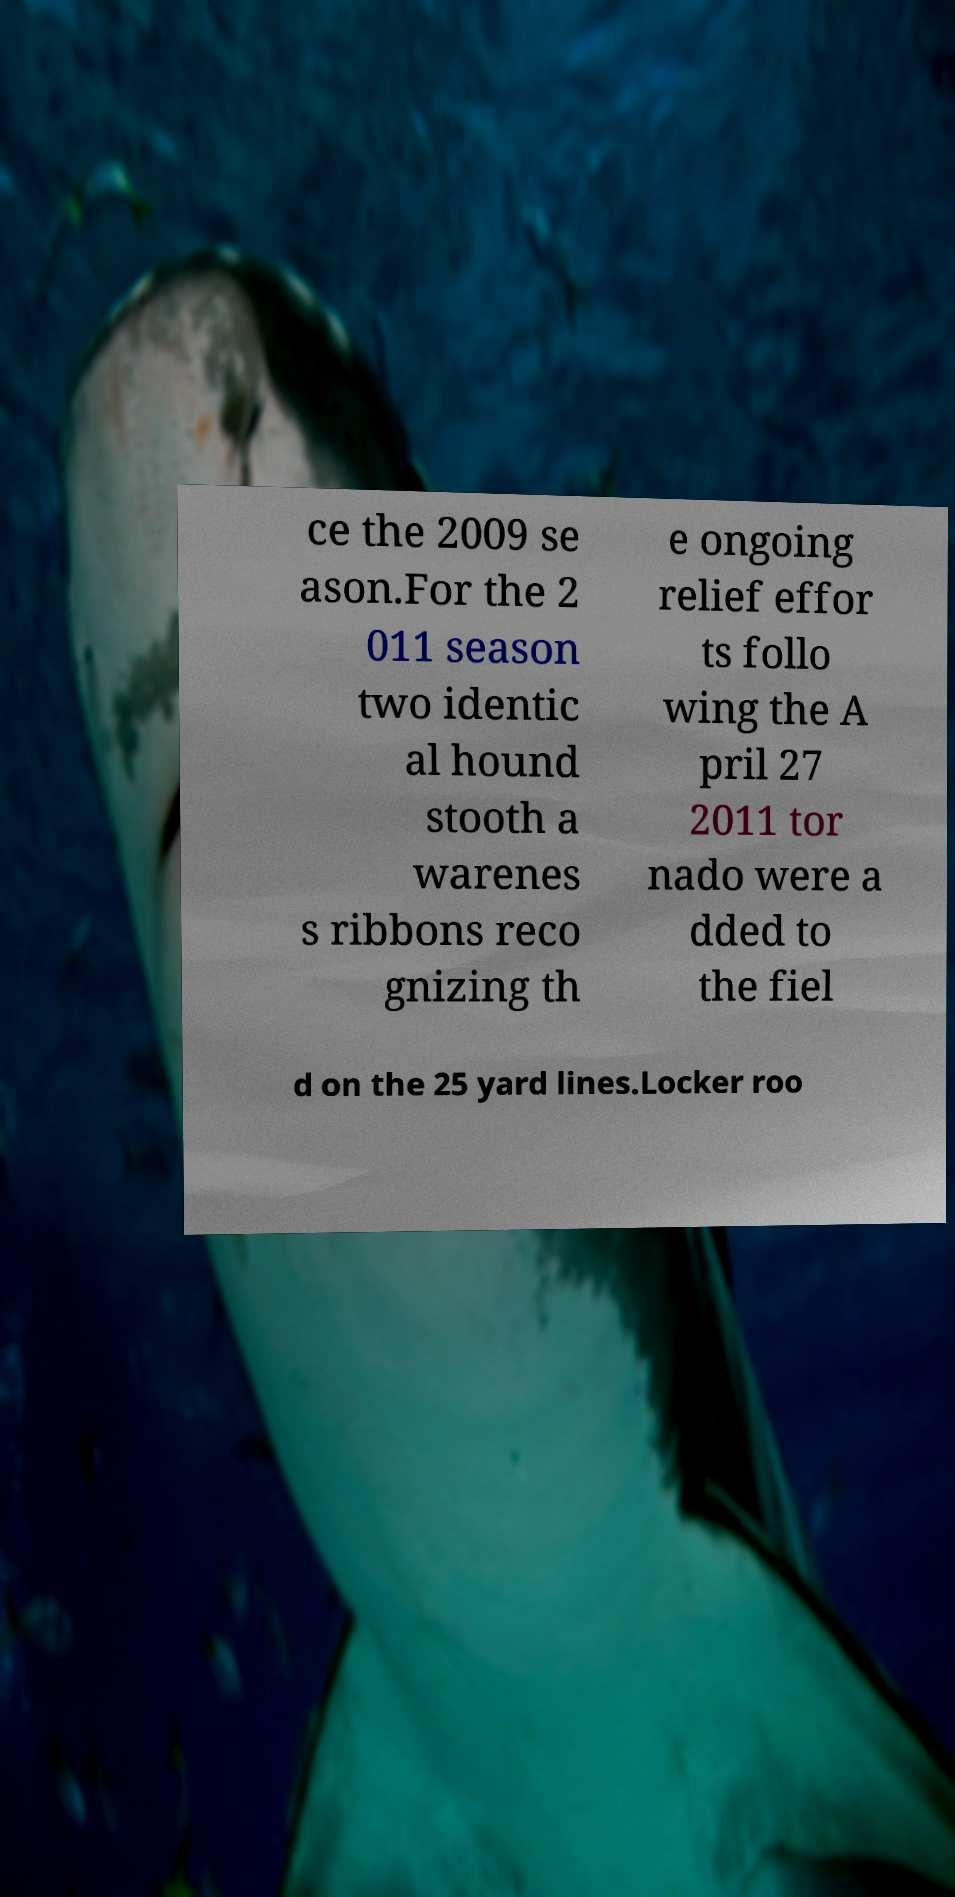Can you read and provide the text displayed in the image?This photo seems to have some interesting text. Can you extract and type it out for me? ce the 2009 se ason.For the 2 011 season two identic al hound stooth a warenes s ribbons reco gnizing th e ongoing relief effor ts follo wing the A pril 27 2011 tor nado were a dded to the fiel d on the 25 yard lines.Locker roo 